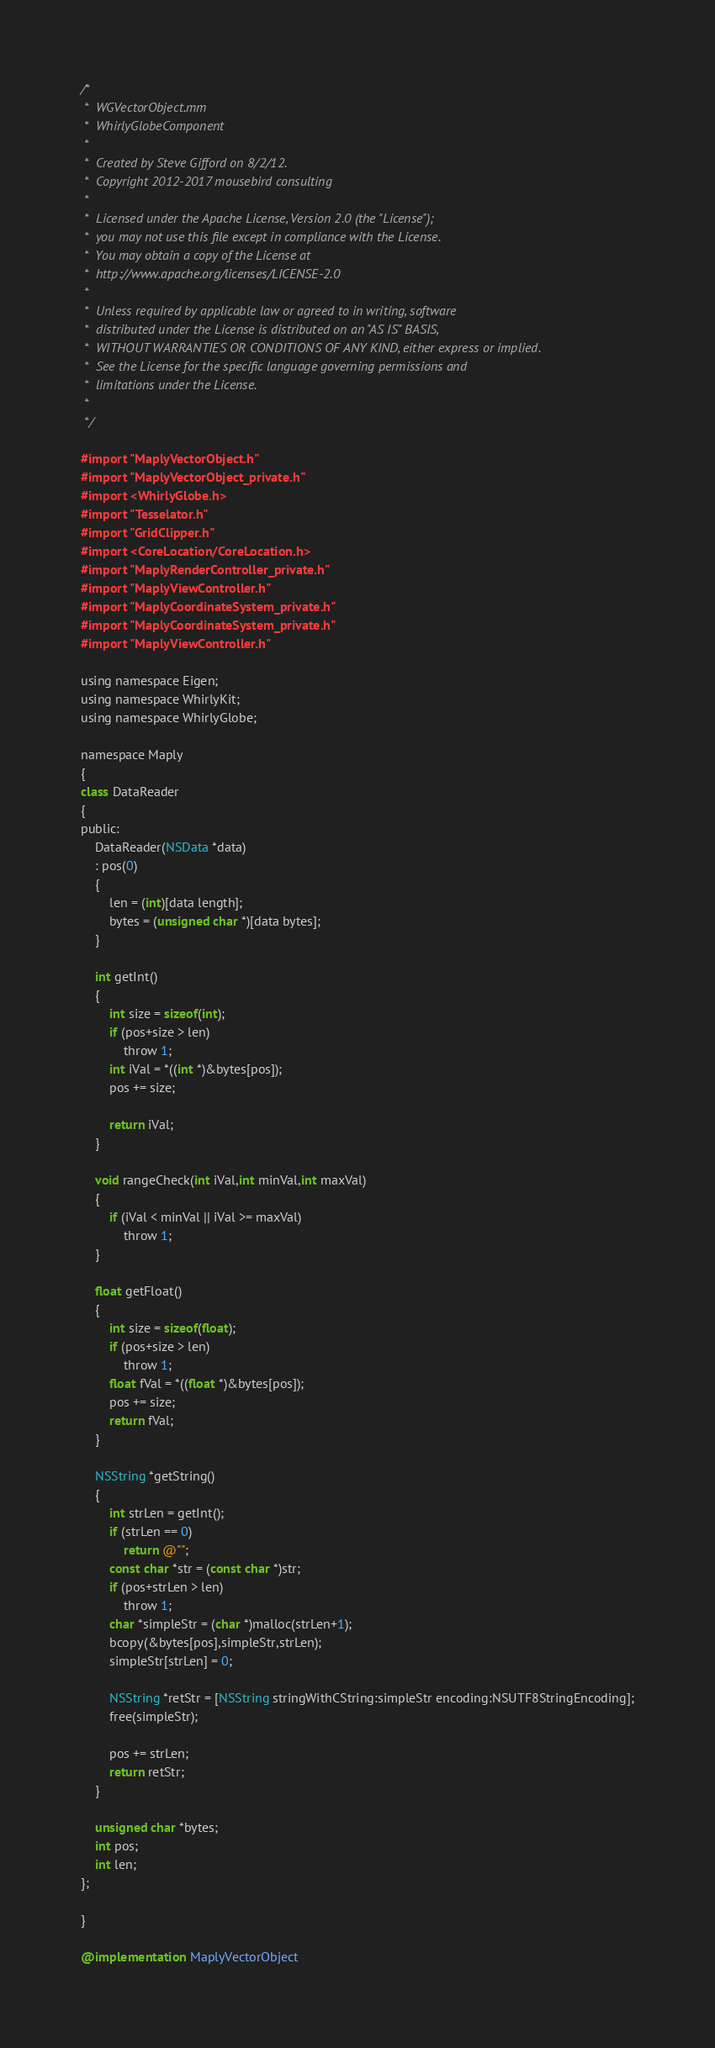<code> <loc_0><loc_0><loc_500><loc_500><_ObjectiveC_>/*
 *  WGVectorObject.mm
 *  WhirlyGlobeComponent
 *
 *  Created by Steve Gifford on 8/2/12.
 *  Copyright 2012-2017 mousebird consulting
 *
 *  Licensed under the Apache License, Version 2.0 (the "License");
 *  you may not use this file except in compliance with the License.
 *  You may obtain a copy of the License at
 *  http://www.apache.org/licenses/LICENSE-2.0
 *
 *  Unless required by applicable law or agreed to in writing, software
 *  distributed under the License is distributed on an "AS IS" BASIS,
 *  WITHOUT WARRANTIES OR CONDITIONS OF ANY KIND, either express or implied.
 *  See the License for the specific language governing permissions and
 *  limitations under the License.
 *
 */

#import "MaplyVectorObject.h"
#import "MaplyVectorObject_private.h"
#import <WhirlyGlobe.h>
#import "Tesselator.h"
#import "GridClipper.h"
#import <CoreLocation/CoreLocation.h>
#import "MaplyRenderController_private.h"
#import "MaplyViewController.h"
#import "MaplyCoordinateSystem_private.h"
#import "MaplyCoordinateSystem_private.h"
#import "MaplyViewController.h"

using namespace Eigen;
using namespace WhirlyKit;
using namespace WhirlyGlobe;

namespace Maply
{
class DataReader
{
public:
    DataReader(NSData *data)
    : pos(0)
    {
        len = (int)[data length];
        bytes = (unsigned char *)[data bytes];
    }
    
    int getInt()
    {
        int size = sizeof(int);
        if (pos+size > len)
            throw 1;
        int iVal = *((int *)&bytes[pos]);
        pos += size;
        
        return iVal;
    }
    
    void rangeCheck(int iVal,int minVal,int maxVal)
    {
        if (iVal < minVal || iVal >= maxVal)
            throw 1;
    }
    
    float getFloat()
    {
        int size = sizeof(float);
        if (pos+size > len)
            throw 1;
        float fVal = *((float *)&bytes[pos]);
        pos += size;
        return fVal;
    }
    
    NSString *getString()
    {
        int strLen = getInt();
        if (strLen == 0)
            return @"";
        const char *str = (const char *)str;
        if (pos+strLen > len)
            throw 1;
        char *simpleStr = (char *)malloc(strLen+1);
        bcopy(&bytes[pos],simpleStr,strLen);
        simpleStr[strLen] = 0;
        
        NSString *retStr = [NSString stringWithCString:simpleStr encoding:NSUTF8StringEncoding];
        free(simpleStr);
        
        pos += strLen;
        return retStr;
    }
    
    unsigned char *bytes;
    int pos;
    int len;
};
            
}

@implementation MaplyVectorObject
</code> 